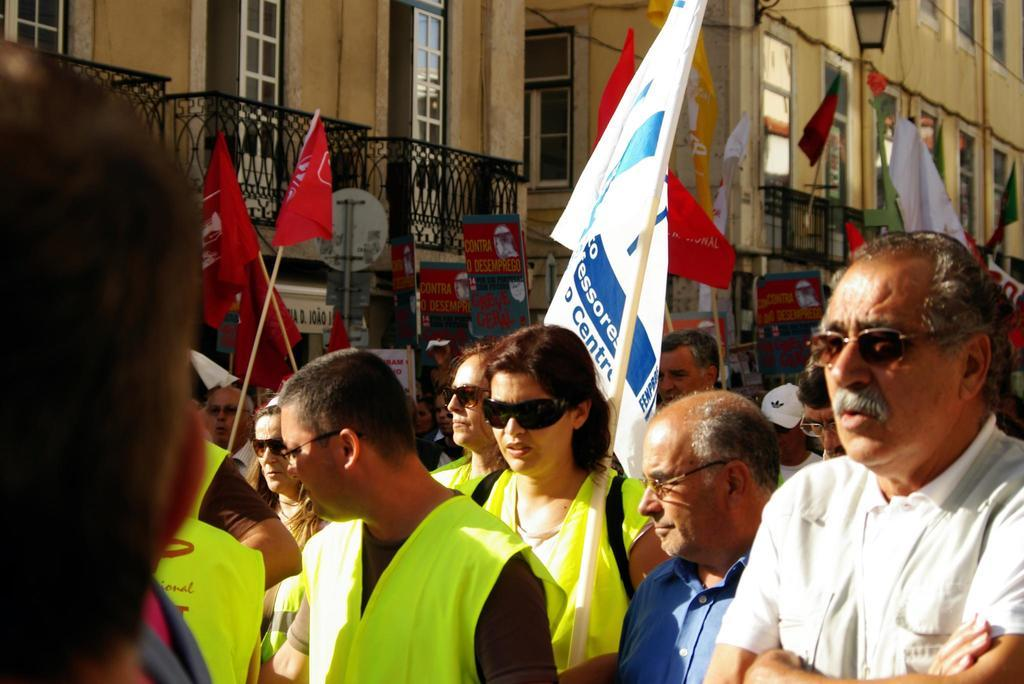What is happening in the image? There is a group of people in the image, and they are walking on a road. What are some of the people holding? Some of the people are holding flags. What can be seen in the background of the image? There is a building visible in the image. What type of vegetable is being measured with a spoon in the image? There is no vegetable or spoon present in the image. 